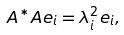Convert formula to latex. <formula><loc_0><loc_0><loc_500><loc_500>A ^ { * } A e _ { i } = \lambda _ { i } ^ { 2 } e _ { i } ,</formula> 